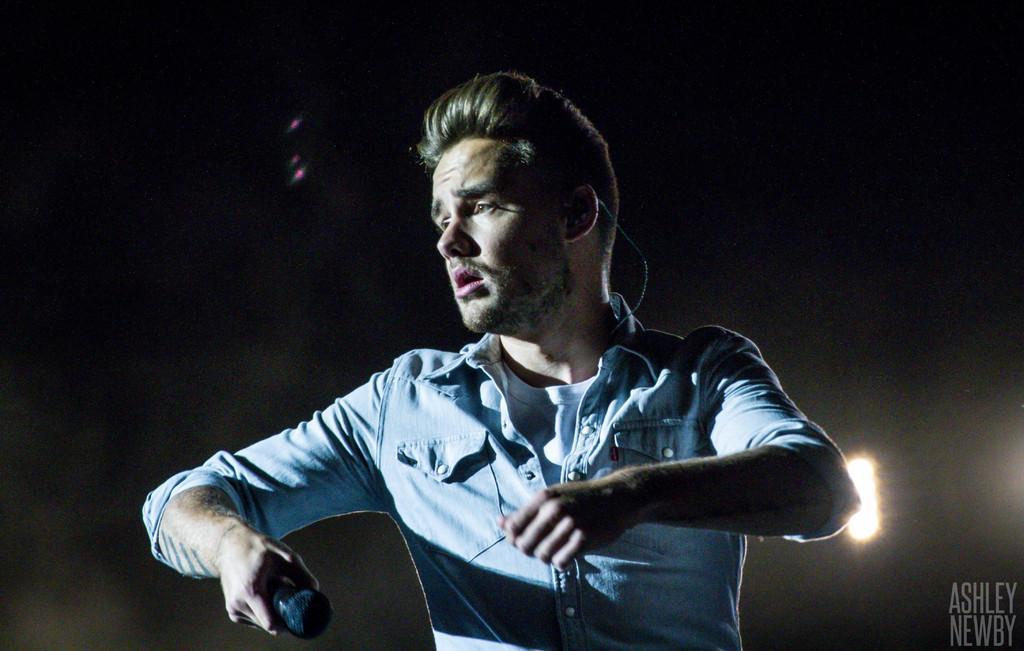Could you give a brief overview of what you see in this image? In this image there is man he is holding mic. He is wearing a blue shirt. 